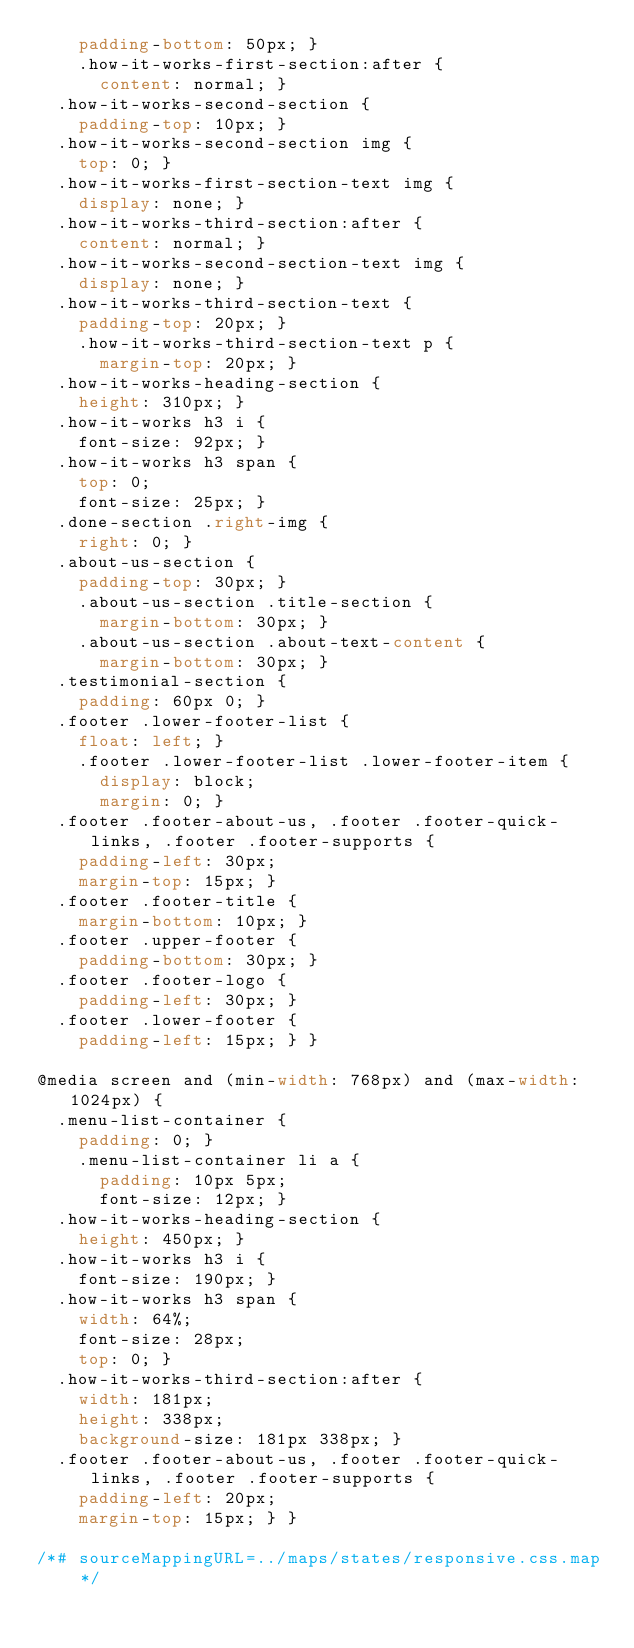Convert code to text. <code><loc_0><loc_0><loc_500><loc_500><_CSS_>    padding-bottom: 50px; }
    .how-it-works-first-section:after {
      content: normal; }
  .how-it-works-second-section {
    padding-top: 10px; }
  .how-it-works-second-section img {
    top: 0; }
  .how-it-works-first-section-text img {
    display: none; }
  .how-it-works-third-section:after {
    content: normal; }
  .how-it-works-second-section-text img {
    display: none; }
  .how-it-works-third-section-text {
    padding-top: 20px; }
    .how-it-works-third-section-text p {
      margin-top: 20px; }
  .how-it-works-heading-section {
    height: 310px; }
  .how-it-works h3 i {
    font-size: 92px; }
  .how-it-works h3 span {
    top: 0;
    font-size: 25px; }
  .done-section .right-img {
    right: 0; }
  .about-us-section {
    padding-top: 30px; }
    .about-us-section .title-section {
      margin-bottom: 30px; }
    .about-us-section .about-text-content {
      margin-bottom: 30px; }
  .testimonial-section {
    padding: 60px 0; }
  .footer .lower-footer-list {
    float: left; }
    .footer .lower-footer-list .lower-footer-item {
      display: block;
      margin: 0; }
  .footer .footer-about-us, .footer .footer-quick-links, .footer .footer-supports {
    padding-left: 30px;
    margin-top: 15px; }
  .footer .footer-title {
    margin-bottom: 10px; }
  .footer .upper-footer {
    padding-bottom: 30px; }
  .footer .footer-logo {
    padding-left: 30px; }
  .footer .lower-footer {
    padding-left: 15px; } }

@media screen and (min-width: 768px) and (max-width: 1024px) {
  .menu-list-container {
    padding: 0; }
    .menu-list-container li a {
      padding: 10px 5px;
      font-size: 12px; }
  .how-it-works-heading-section {
    height: 450px; }
  .how-it-works h3 i {
    font-size: 190px; }
  .how-it-works h3 span {
    width: 64%;
    font-size: 28px;
    top: 0; }
  .how-it-works-third-section:after {
    width: 181px;
    height: 338px;
    background-size: 181px 338px; }
  .footer .footer-about-us, .footer .footer-quick-links, .footer .footer-supports {
    padding-left: 20px;
    margin-top: 15px; } }

/*# sourceMappingURL=../maps/states/responsive.css.map */
</code> 